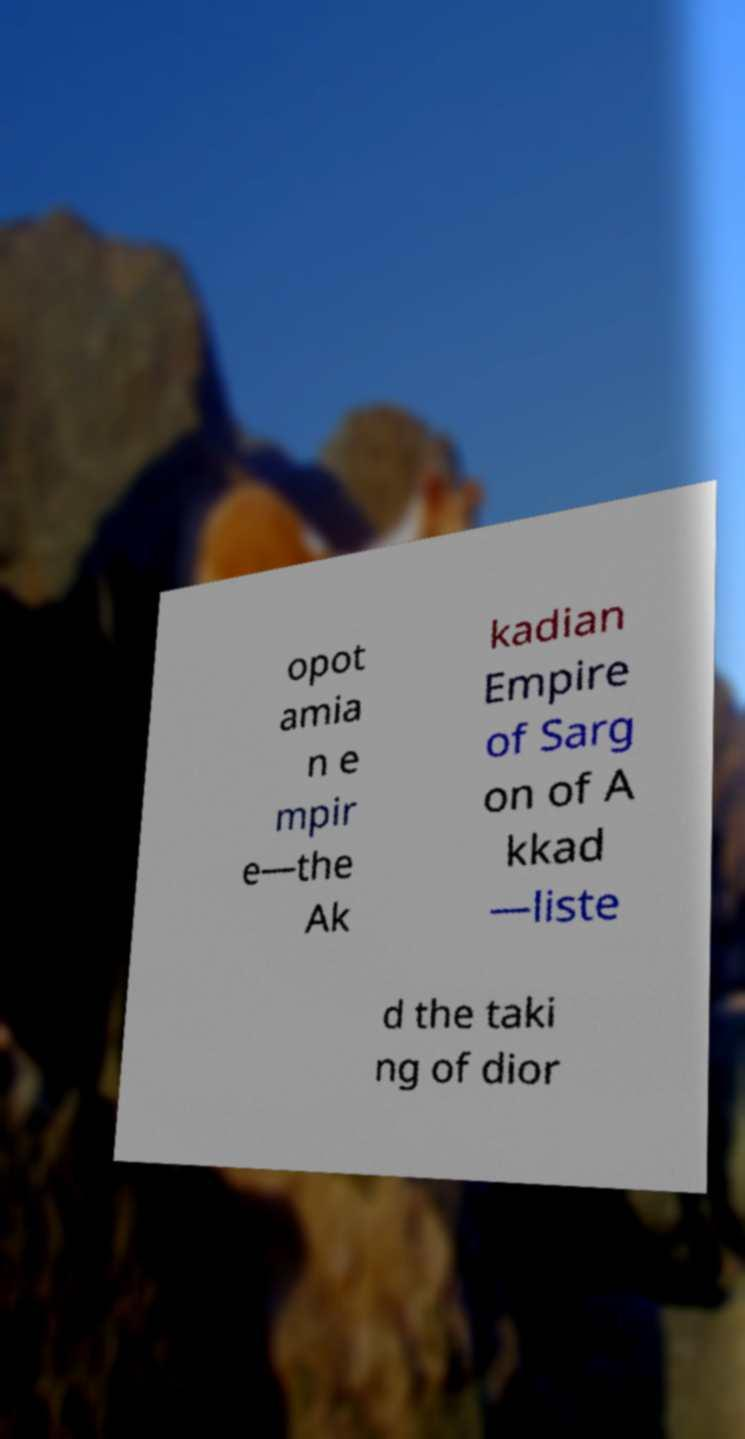For documentation purposes, I need the text within this image transcribed. Could you provide that? opot amia n e mpir e—the Ak kadian Empire of Sarg on of A kkad —liste d the taki ng of dior 